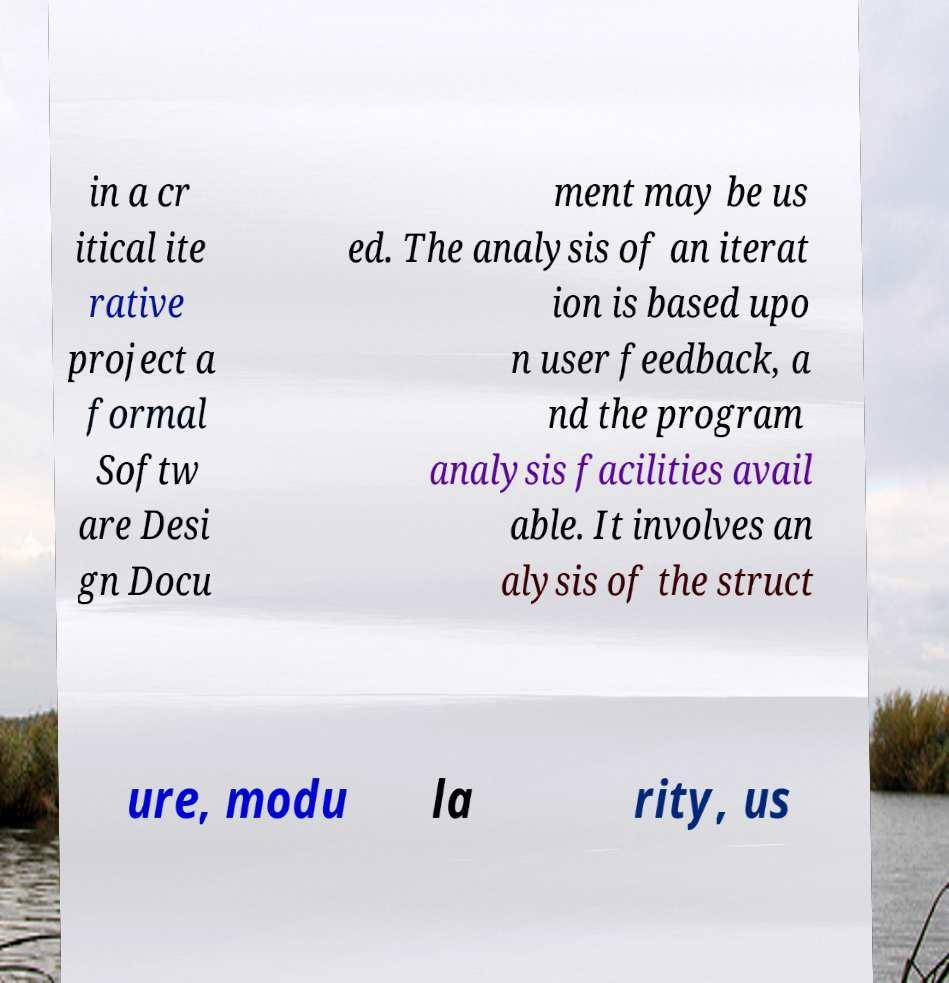Can you read and provide the text displayed in the image?This photo seems to have some interesting text. Can you extract and type it out for me? in a cr itical ite rative project a formal Softw are Desi gn Docu ment may be us ed. The analysis of an iterat ion is based upo n user feedback, a nd the program analysis facilities avail able. It involves an alysis of the struct ure, modu la rity, us 